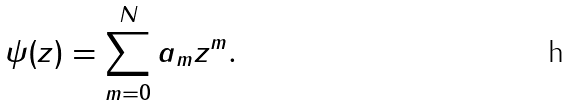Convert formula to latex. <formula><loc_0><loc_0><loc_500><loc_500>\psi ( z ) = \sum _ { m = 0 } ^ { N } a _ { m } z ^ { m } .</formula> 